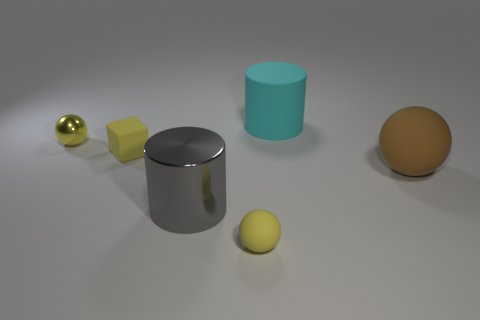Subtract all cyan cylinders. Subtract all green balls. How many cylinders are left? 1 Add 1 large purple rubber things. How many objects exist? 7 Subtract all cubes. How many objects are left? 5 Add 1 large cyan rubber cylinders. How many large cyan rubber cylinders are left? 2 Add 1 red cubes. How many red cubes exist? 1 Subtract 0 cyan blocks. How many objects are left? 6 Subtract all matte cubes. Subtract all small purple metal blocks. How many objects are left? 5 